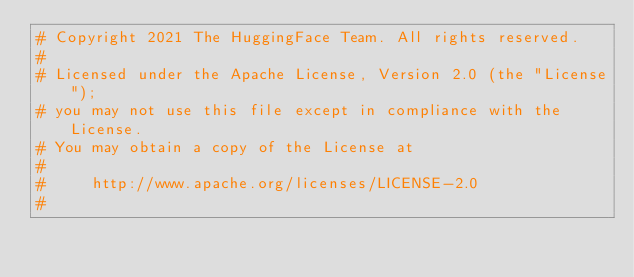Convert code to text. <code><loc_0><loc_0><loc_500><loc_500><_Python_># Copyright 2021 The HuggingFace Team. All rights reserved.
#
# Licensed under the Apache License, Version 2.0 (the "License");
# you may not use this file except in compliance with the License.
# You may obtain a copy of the License at
#
#     http://www.apache.org/licenses/LICENSE-2.0
#</code> 